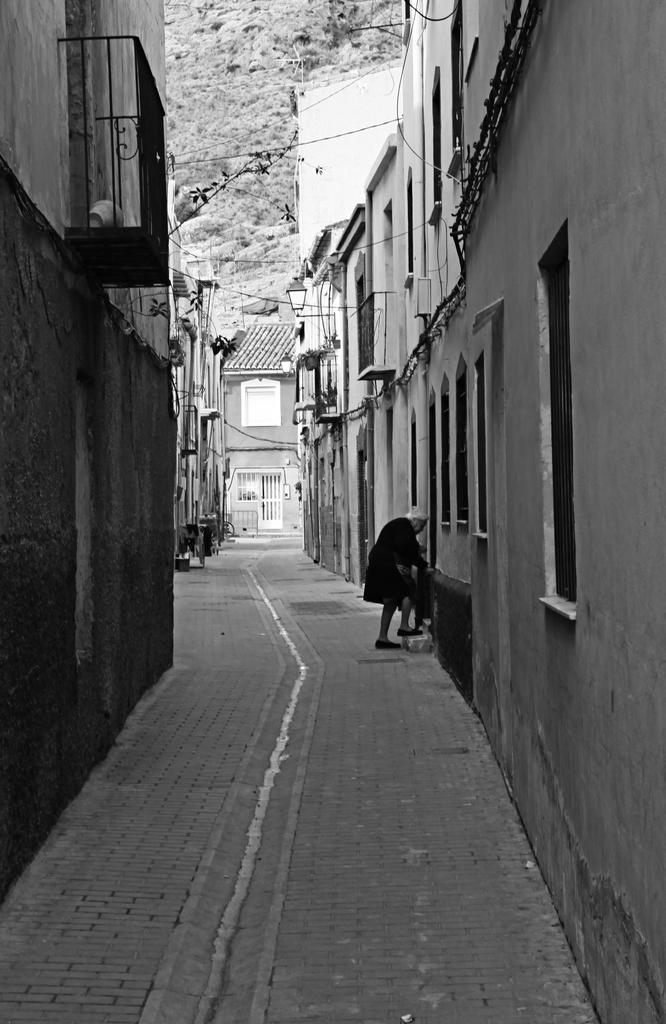Who or what is present in the image? There is a person in the image. Where is the person located in relation to the buildings? The person is between buildings. What can be seen at the top of the image? There is a hill at the top of the image. What type of music can be heard coming from the cave in the image? There is no cave present in the image, so it is not possible to determine what, if any, music might be heard. 